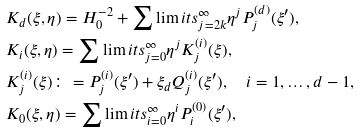<formula> <loc_0><loc_0><loc_500><loc_500>& K _ { d } ( \xi , \eta ) = H _ { 0 } ^ { - 2 } + \sum \lim i t s _ { j = 2 k } ^ { \infty } \eta ^ { j } P _ { j } ^ { ( d ) } ( \xi ^ { \prime } ) , \\ & K _ { i } ( \xi , \eta ) = \sum \lim i t s _ { j = 0 } ^ { \infty } \eta ^ { j } K _ { j } ^ { ( i ) } ( \xi ) , \\ & K _ { j } ^ { ( i ) } ( \xi ) \colon = P _ { j } ^ { ( i ) } ( \xi ^ { \prime } ) + \xi _ { d } Q _ { j } ^ { ( i ) } ( \xi ^ { \prime } ) , \quad i = 1 , \dots , d - 1 , \\ & K _ { 0 } ( \xi , \eta ) = \sum \lim i t s _ { i = 0 } ^ { \infty } \eta ^ { i } P _ { i } ^ { ( 0 ) } ( \xi ^ { \prime } ) ,</formula> 